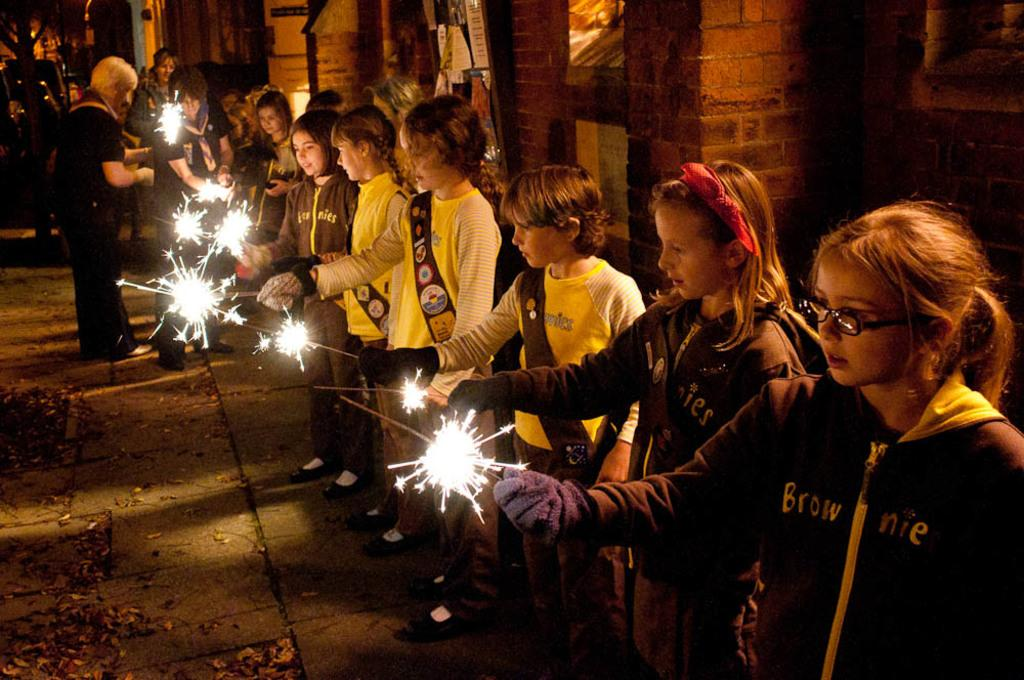Who is present in the image? There are children and persons in the image. What are the children and persons holding in the image? They are holding fireworks. What can be seen in the background of the image? There is a building and a tree in the background of the background of the image. What type of patch is being ironed by the children in the image? There is no patch or iron present in the image; the children and persons are holding fireworks. 